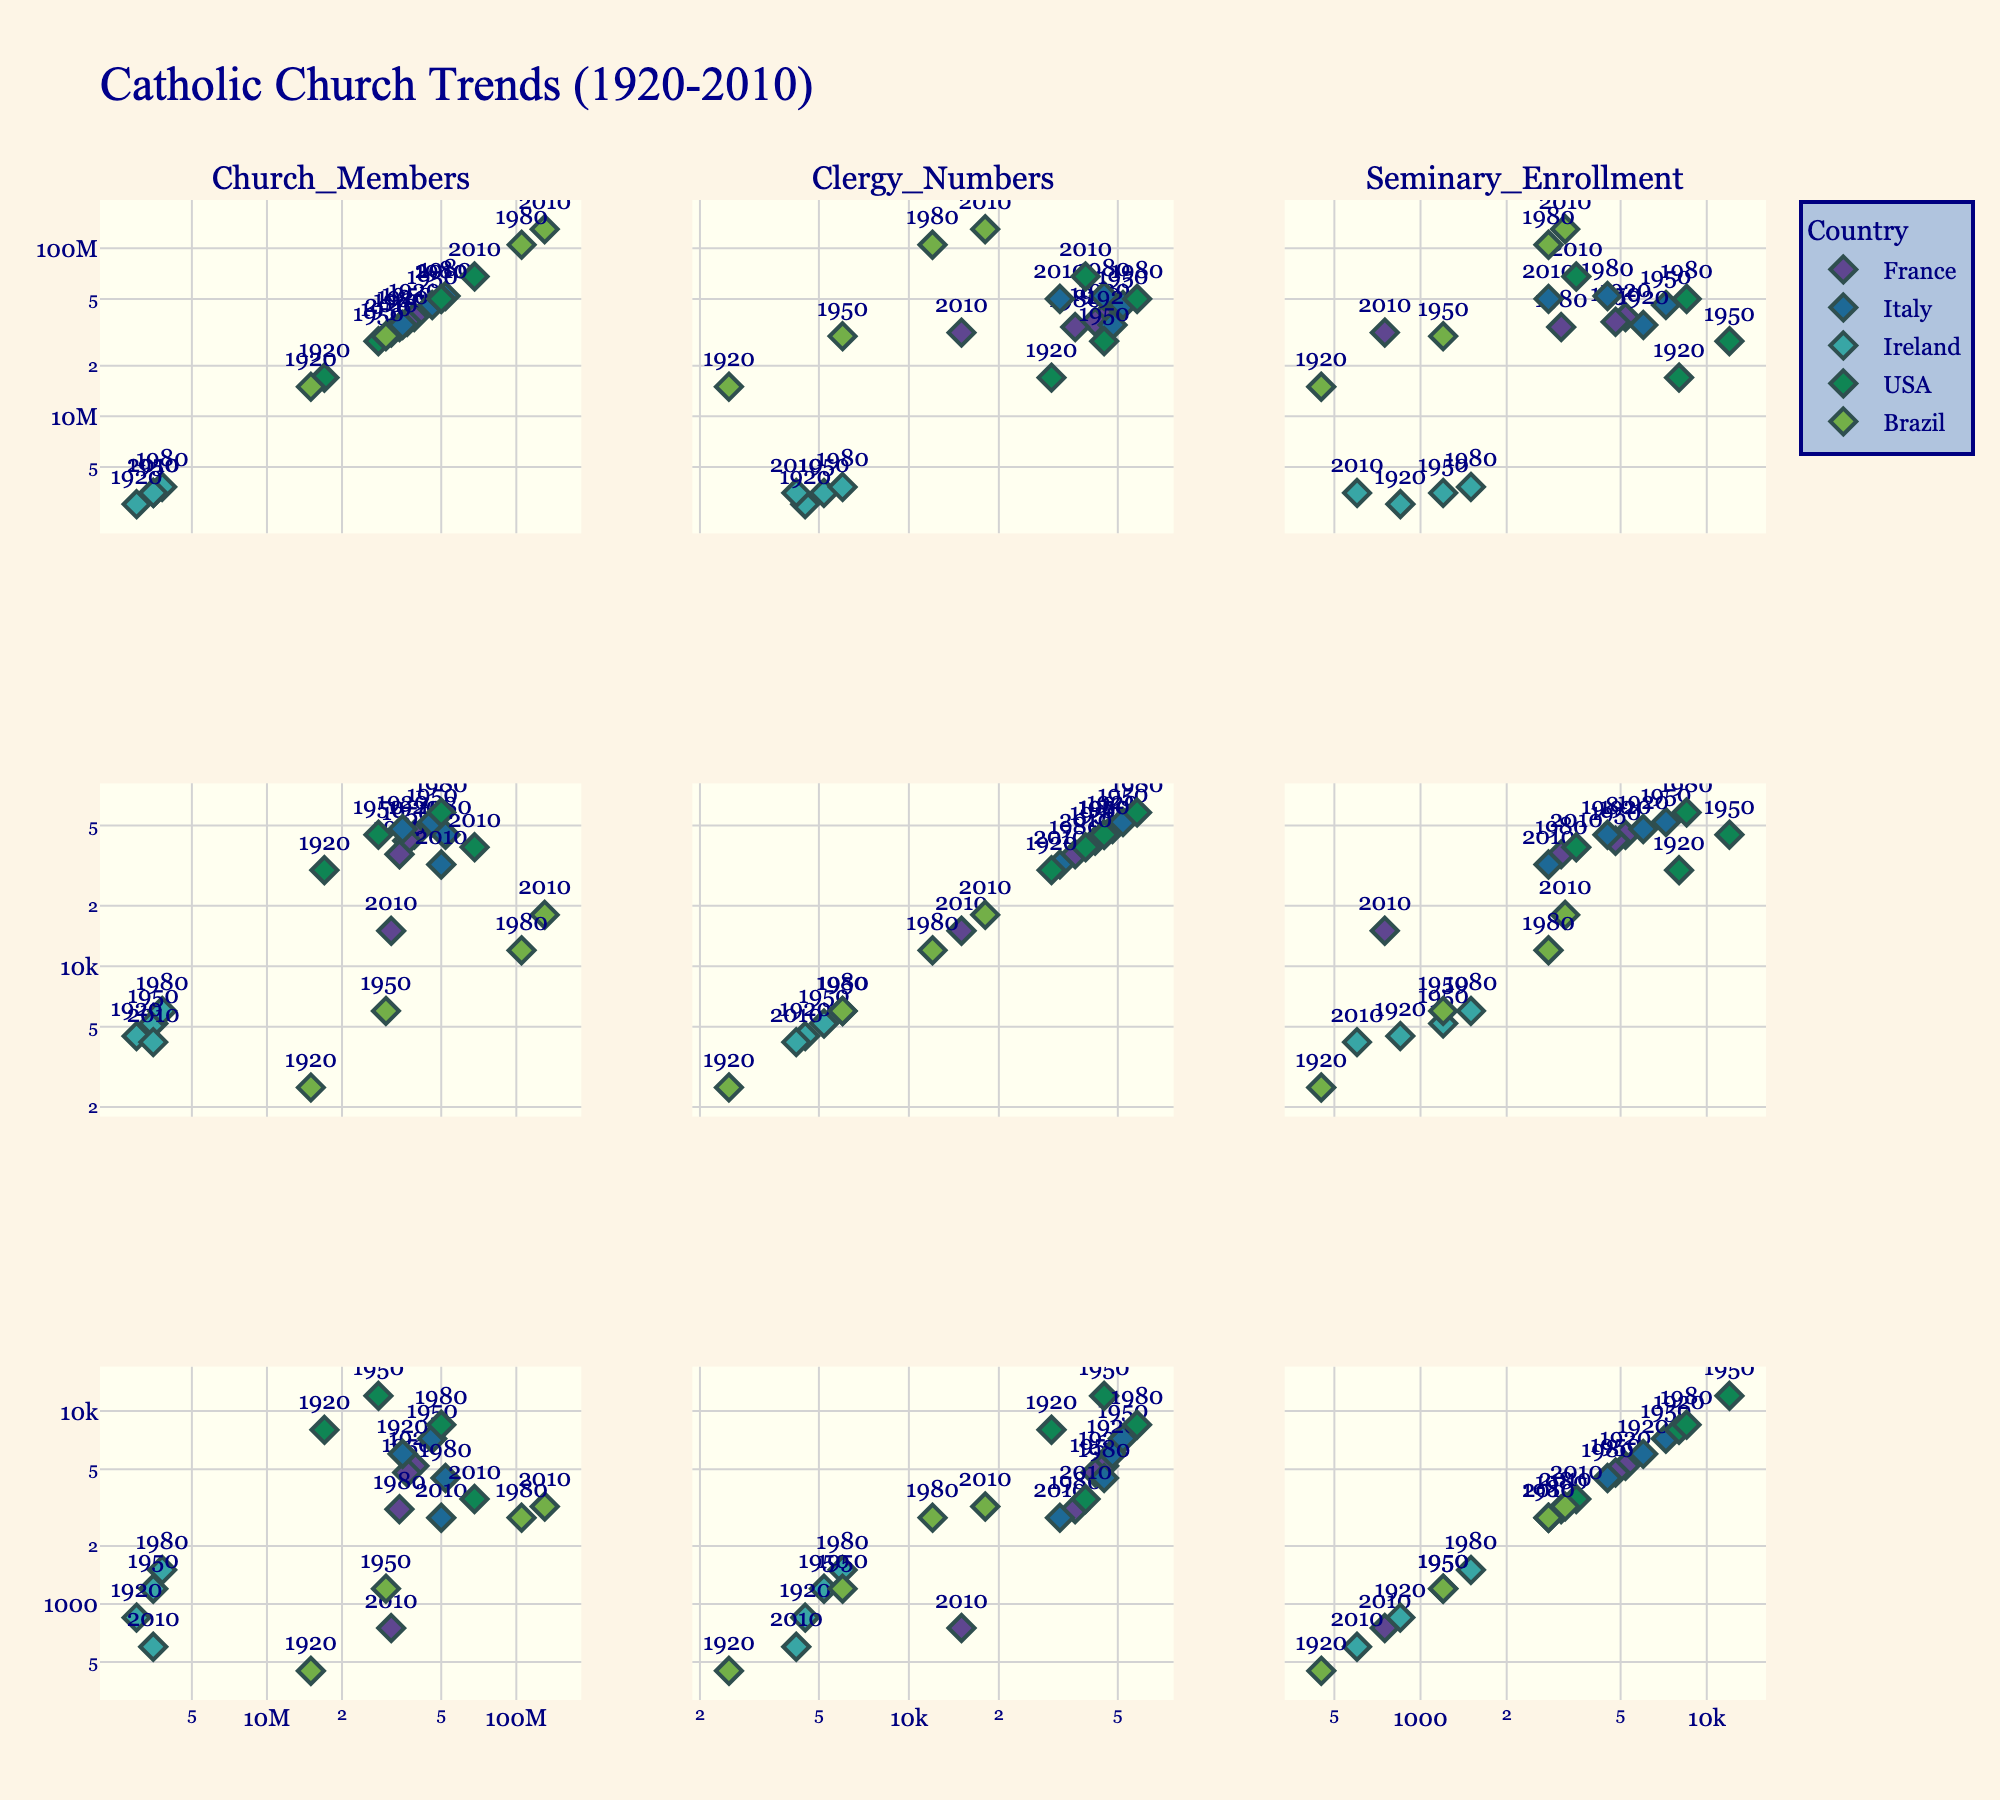Which country shows the largest decrease in clergy numbers from 1920 to 2010? To determine which country shows the largest decrease in clergy numbers, we need to look at the vertical axis for "Clergy Numbers" across different countries and compare the 1920 and 2010 points. From the scatterplot matrix, we observe that France has the largest drop from 45,000 in 1920 to 15,000 in 2010, amounting to a decrease of 30,000.
Answer: France Between 1920 and 2010, did the USA or Brazil see a larger increase in Church membership? By comparing the horizontal axis for "Church Memberships" in 1920 and 2010 for both the USA and Brazil, the USA increased from 17 million to 68 million (an increase of 51 million) while Brazil increased from 15 million to 130 million (an increase of 115 million). Hence, Brazil saw a larger increase.
Answer: Brazil Which country has the highest seminary enrollment in 1950? For the year 1950, look at the vertical axis where "Seminary Enrollment" is plotted. The USA has the highest value at 12,000.
Answer: USA Has Italy's church membership increased, decreased, or remained stable from 1980 to 2010? To determine the trend in Italy's church membership from 1980 to 2010, observe the horizontal axis capturing "Church Members". The church membership slightly decreased from 52 million to 50 million.
Answer: Decreased Among France and Ireland, which country had a higher seminary enrollment in 1980? For the year 1980, look at the "Seminary Enrollment" axis, noting the positions of France and Ireland. France had 3,100, whereas Ireland had 1,500. Therefore, France had a higher seminary enrollment.
Answer: France Considering the country with the highest increase in Church members from 1920 to 2010, what was the starting and ending values? Brazil had the highest increase in Church members from 1920 to 2010. The values went from 15 million in 1920 to 130 million in 2010.
Answer: 15 million and 130 million Which country experienced the most significant decline in seminary enrollment between 1950 and 2010? Examine the "Seminary Enrollment" axis for 1950 and 2010. France's numbers dropped from 4,800 in 1950 to 750 in 2010, making it the most substantial decline of 4,050.
Answer: France Does any country show stability in clergy numbers from 1920 to 2010? Scan the "Clergy Numbers" axis across different years to identify any country with negligible change. Only Brazil shows relative stability, increasing slightly from 2,500 to 18,000 over the century but without major fluctuations.
Answer: No What is the relationship between Church members and seminary enrollment in the USA? To understand the relationship, look at the scatterplots concerning "Church Members" and "Seminary Enrollment" for the USA. As church membership increases, seminary enrollment initially rises but then significantly falls post-1980. This suggests an initial correlation that weakens over time.
Answer: Weakens over time 